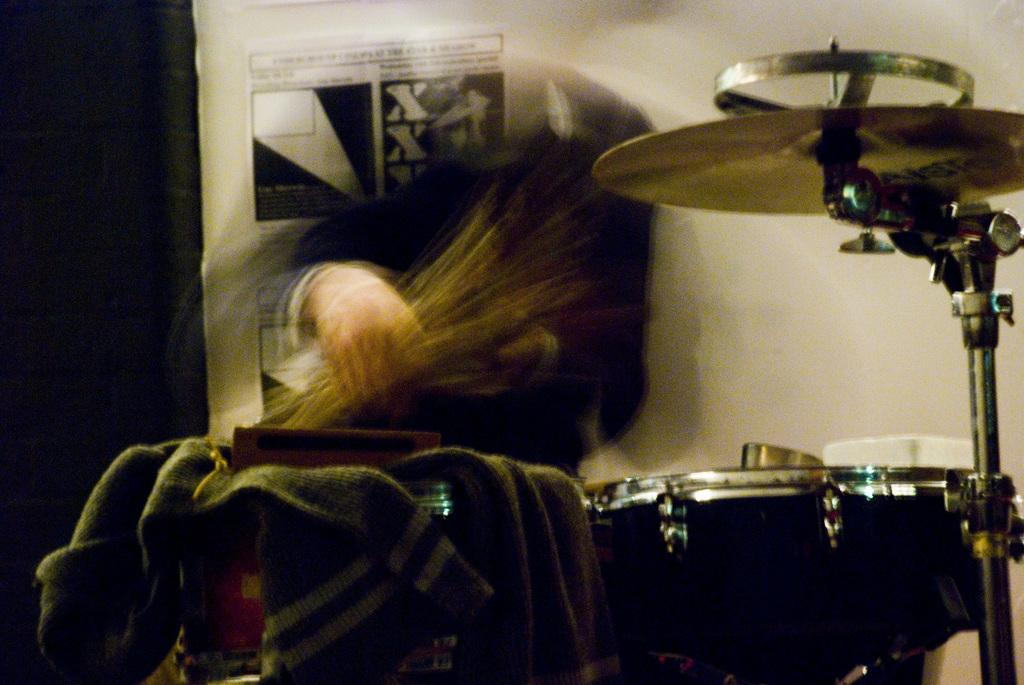What is the main subject of the blurry image? There is a person holding an object in the blurry image. What else can be seen in the image besides the person? There are musical instruments and clothes visible in the image. What is on the wall in the background of the image? There is a poster with text on the wall in the background. How many goldfish are swimming in the person's head in the image? There are no goldfish present in the image, and the person's head is not visible. 